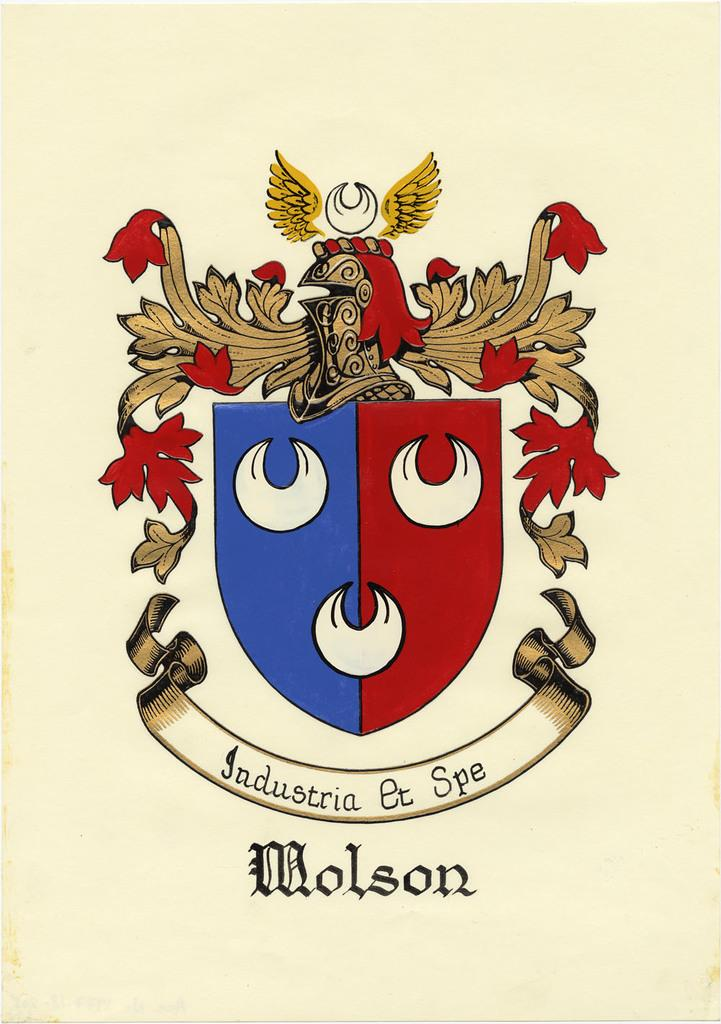<image>
Summarize the visual content of the image. A emblem displayed in blue and red with the words Industria Et Spe Molson 